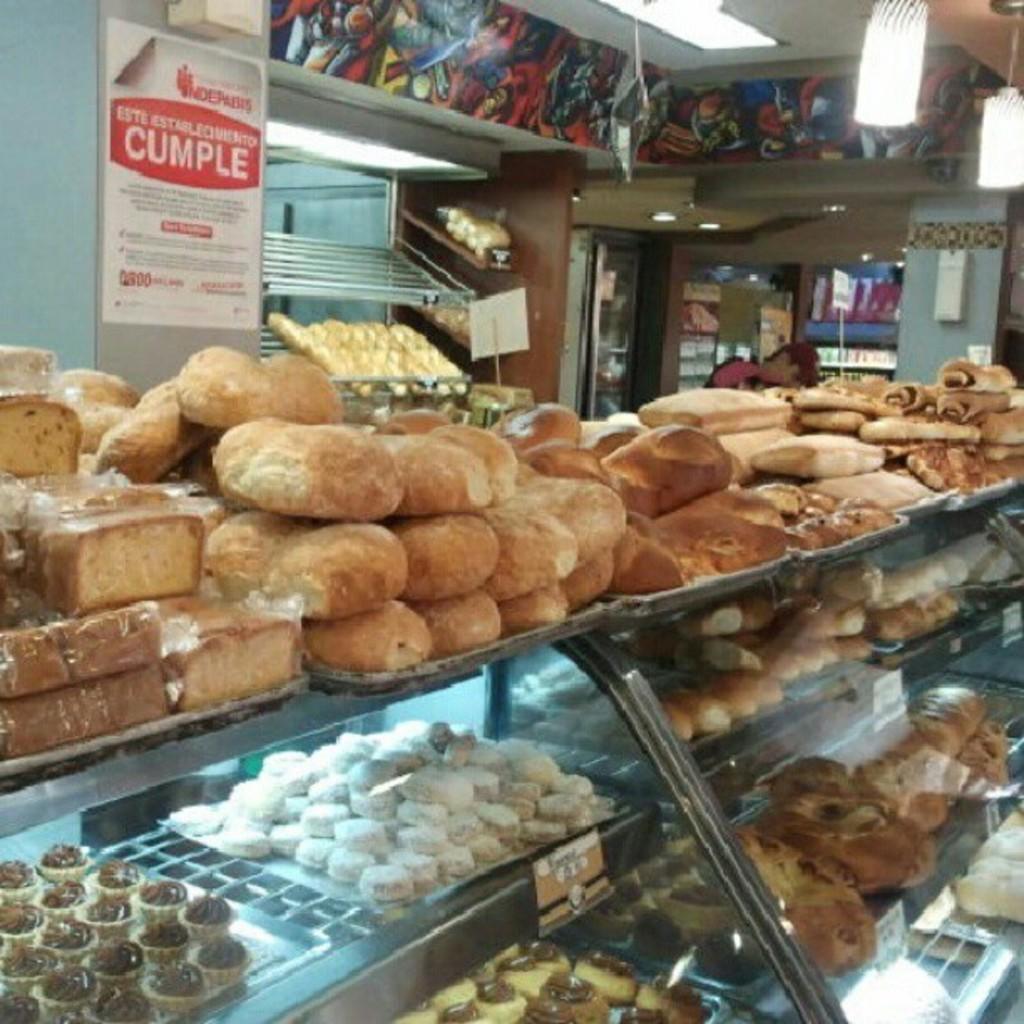Describe this image in one or two sentences. In this image, we can see so many eatable things and items are placed on the trays. Here we can see glass, name board, wall, posters and few objects. Top of the image, we can see the ceiling and lights. 